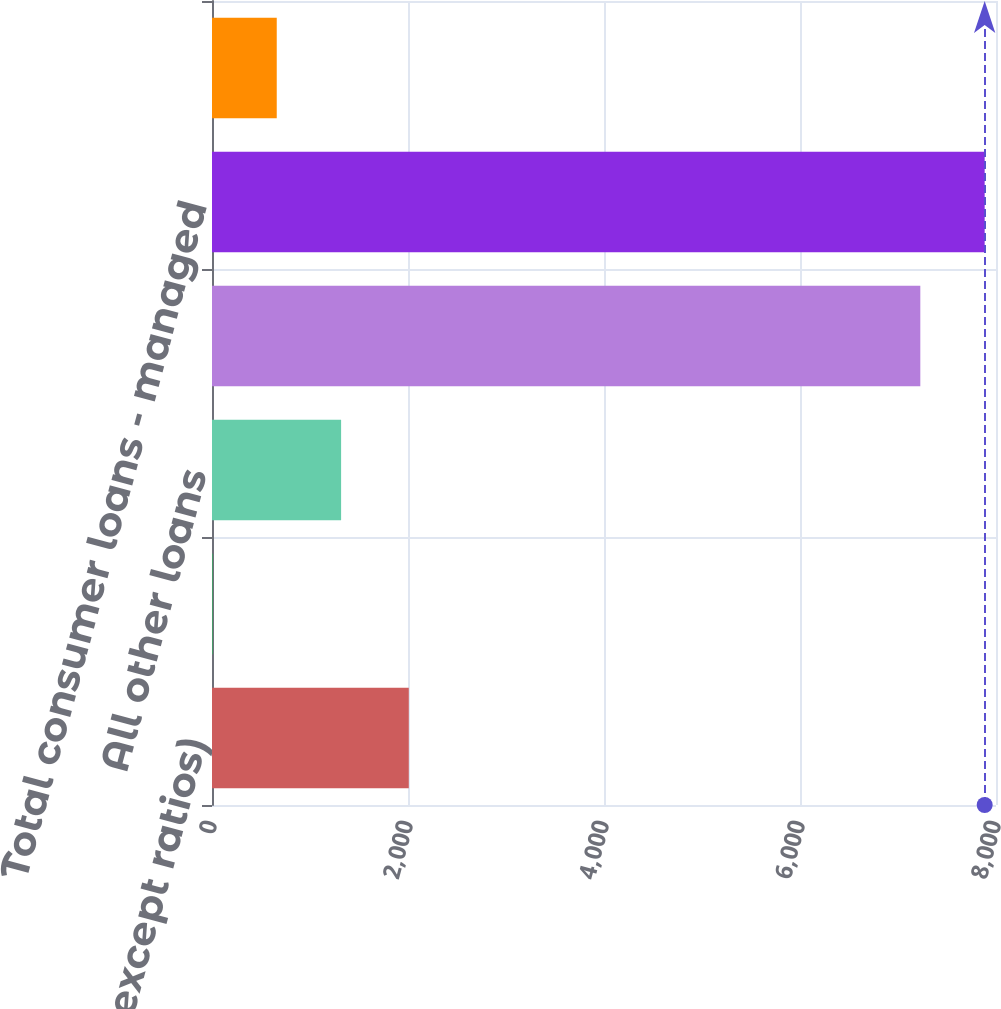Convert chart to OTSL. <chart><loc_0><loc_0><loc_500><loc_500><bar_chart><fcel>(in millions except ratios)<fcel>Credit card - reported<fcel>All other loans<fcel>Total consumer loans -<fcel>Total consumer loans - managed<fcel>Memo Credit card - managed<nl><fcel>2008<fcel>4<fcel>1317.4<fcel>7227.7<fcel>7884.4<fcel>660.7<nl></chart> 